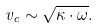Convert formula to latex. <formula><loc_0><loc_0><loc_500><loc_500>v _ { c } \sim \sqrt { \kappa \cdot \omega } .</formula> 